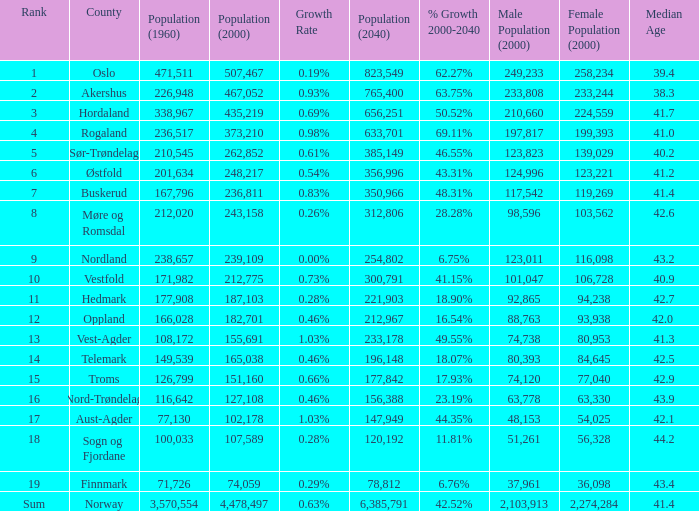What was the population of a county in 1960 that had a population of 467,052 in 2000 and 78,812 in 2040? None. 